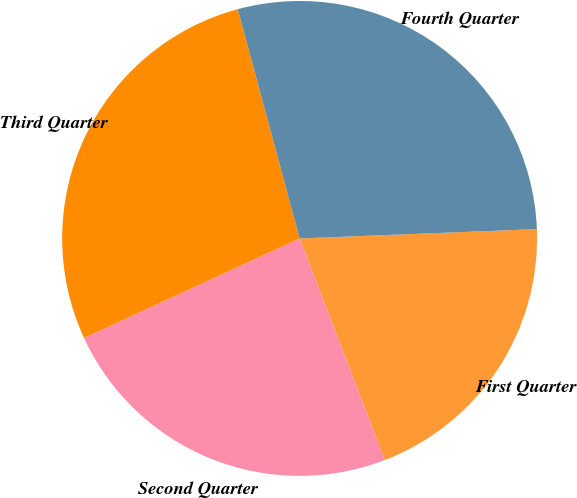Convert chart. <chart><loc_0><loc_0><loc_500><loc_500><pie_chart><fcel>First Quarter<fcel>Second Quarter<fcel>Third Quarter<fcel>Fourth Quarter<nl><fcel>19.79%<fcel>23.95%<fcel>27.69%<fcel>28.57%<nl></chart> 